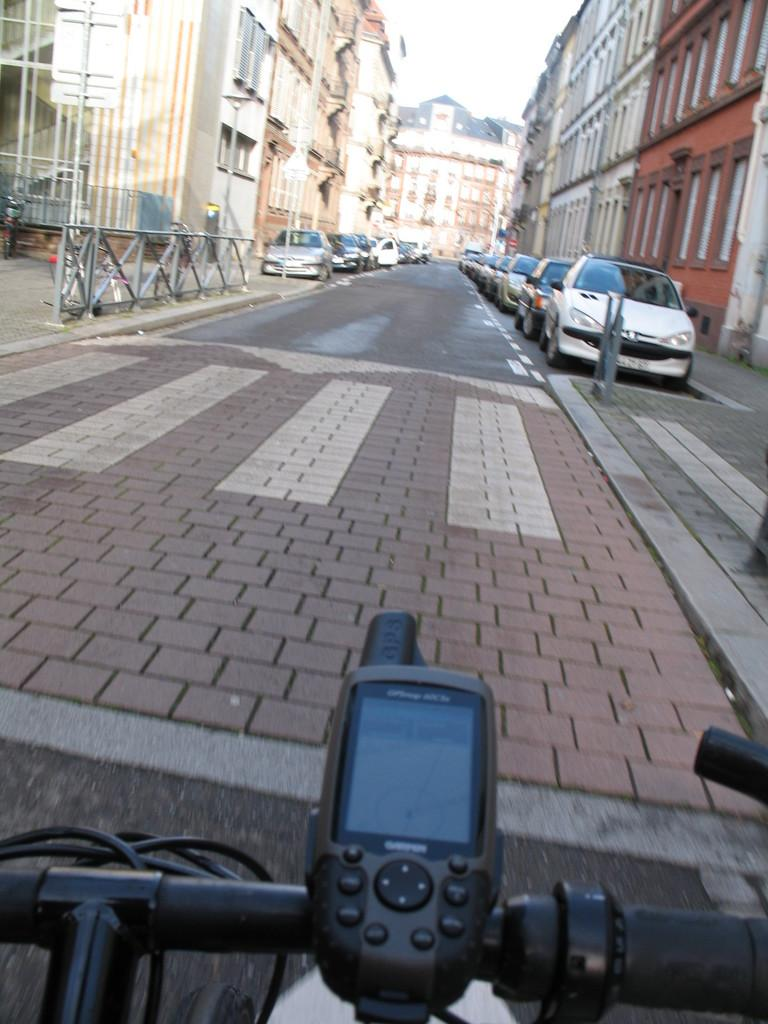What is the main subject in the foreground of the image? There is a bicycle in the foreground of the image. What can be seen in the background of the image? There is a road, vehicles, a side path, buildings, and the sky visible in the background of the image. What type of path is visible in the background of the image? There is a side path in the background of the image. What is the condition of the sky in the image? The sky is visible in the background of the image. What type of glass is being used to connect the buildings in the image? There is no glass or connection between the buildings visible in the image; they are separate structures. What part of the city is depicted in the image? The image does not specifically depict downtown or any other part of the city; it only shows a bicycle, a road, vehicles, a side path, buildings, and the sky. 